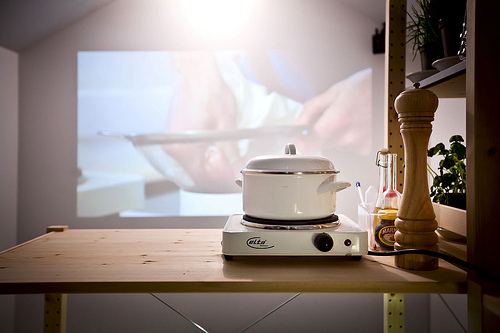<image>
Is there a projection behind the pot? Yes. From this viewpoint, the projection is positioned behind the pot, with the pot partially or fully occluding the projection. Is the cooker on the stove? Yes. Looking at the image, I can see the cooker is positioned on top of the stove, with the stove providing support. 